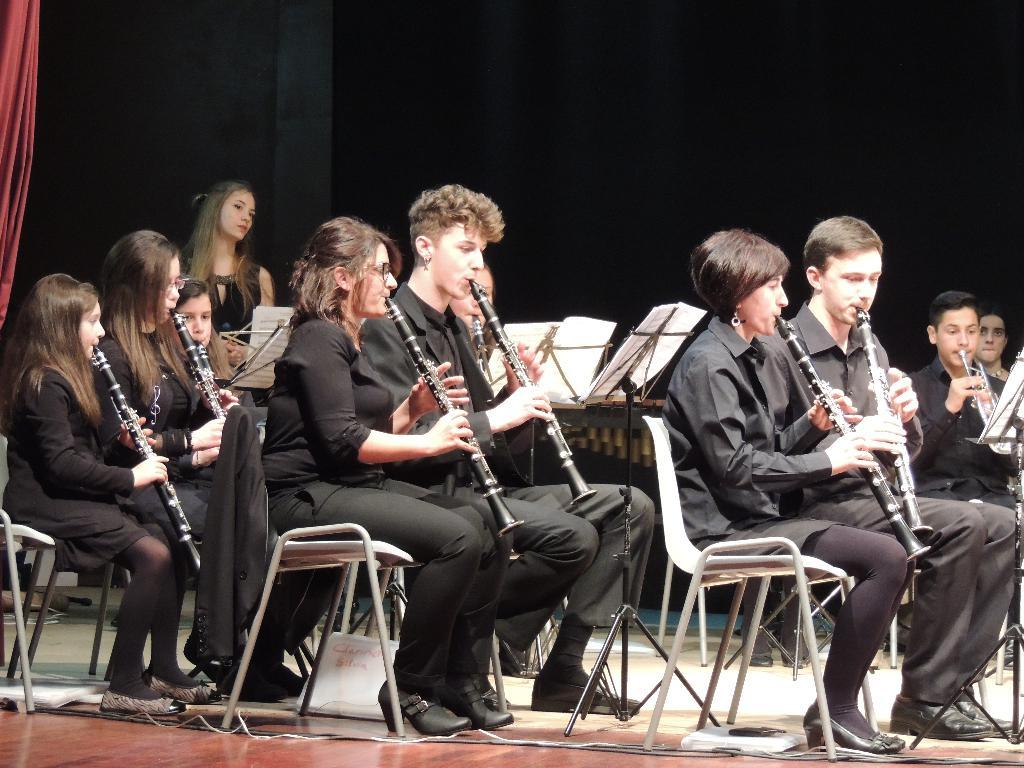What are the people in the image doing? The people in the image are sitting on chairs and holding musical instruments. Can you describe the girl in the background of the image? There is a girl standing in the background of the image. What might the people in the image be doing together? They might be playing music together, given that they are holding musical instruments. What type of building is depicted in the image? There is no building present in the image; it features people sitting on chairs and holding musical instruments, as well as a girl standing in the background. 